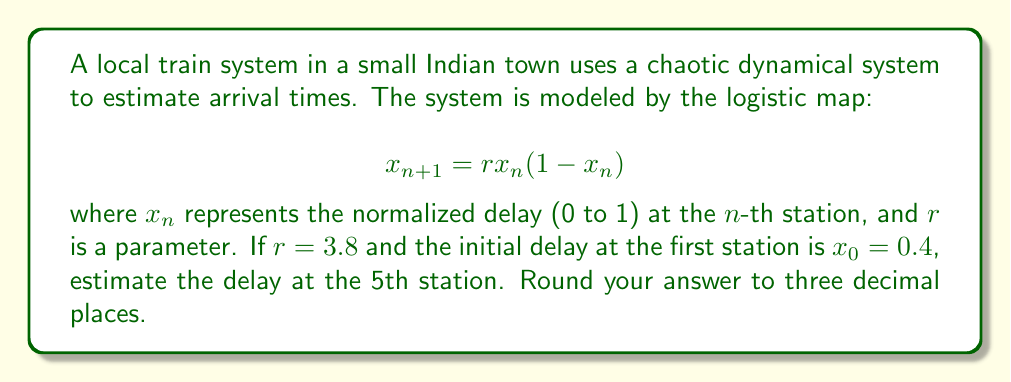Can you answer this question? Let's approach this step-by-step:

1) We are given the logistic map equation: $x_{n+1} = rx_n(1-x_n)$
   With $r = 3.8$ and $x_0 = 0.4$

2) Let's calculate the delay at each station:

   For the 2nd station (n = 1):
   $x_1 = 3.8 * 0.4 * (1-0.4) = 3.8 * 0.4 * 0.6 = 0.912$

   For the 3rd station (n = 2):
   $x_2 = 3.8 * 0.912 * (1-0.912) = 3.8 * 0.912 * 0.088 = 0.305$

   For the 4th station (n = 3):
   $x_3 = 3.8 * 0.305 * (1-0.305) = 3.8 * 0.305 * 0.695 = 0.805$

   For the 5th station (n = 4):
   $x_4 = 3.8 * 0.805 * (1-0.805) = 3.8 * 0.805 * 0.195 = 0.597$

3) Rounding to three decimal places: 0.597

This result shows how the delay fluctuates unpredictably from station to station, demonstrating the chaotic nature of the system.
Answer: 0.597 